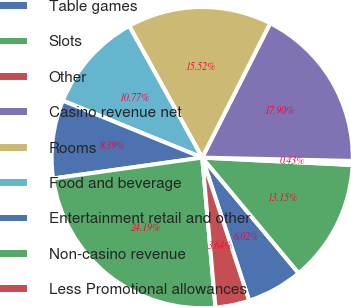Convert chart to OTSL. <chart><loc_0><loc_0><loc_500><loc_500><pie_chart><fcel>Table games<fcel>Slots<fcel>Other<fcel>Casino revenue net<fcel>Rooms<fcel>Food and beverage<fcel>Entertainment retail and other<fcel>Non-casino revenue<fcel>Less Promotional allowances<nl><fcel>6.02%<fcel>13.15%<fcel>0.43%<fcel>17.9%<fcel>15.52%<fcel>10.77%<fcel>8.39%<fcel>24.19%<fcel>3.64%<nl></chart> 